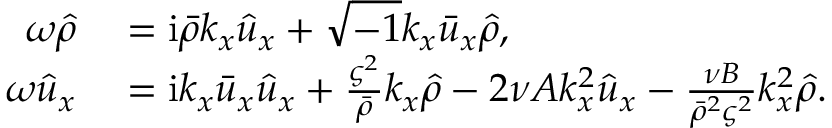<formula> <loc_0><loc_0><loc_500><loc_500>\begin{array} { r l } { \omega \hat { \rho } } & = i \bar { \rho } k _ { x } \hat { u } _ { x } + \sqrt { - 1 } k _ { x } \bar { u } _ { x } \hat { \rho } , } \\ { \omega \hat { u } _ { x } } & = i k _ { x } \bar { u } _ { x } \hat { u } _ { x } + \frac { \varsigma ^ { 2 } } { \bar { \rho } } k _ { x } \hat { \rho } - 2 \nu A k _ { x } ^ { 2 } \hat { u } _ { x } - \frac { \nu B } { \bar { \rho } ^ { 2 } \varsigma ^ { 2 } } k _ { x } ^ { 2 } \hat { \rho } . } \end{array}</formula> 